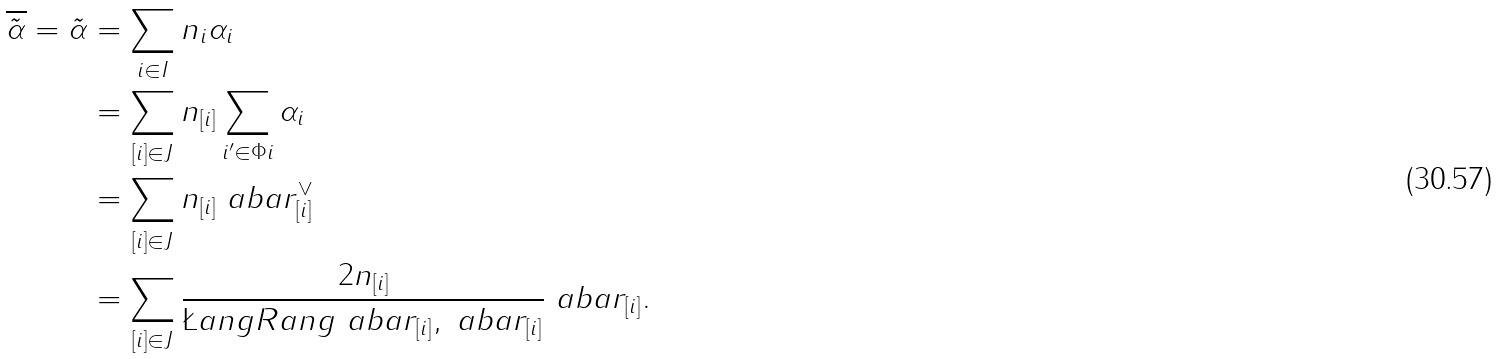<formula> <loc_0><loc_0><loc_500><loc_500>\overline { \tilde { \alpha } } = \tilde { \alpha } & = \sum _ { i \in I } n _ { i } \alpha _ { i } \\ & = \sum _ { [ i ] \in J } n _ { [ i ] } \sum _ { i ^ { \prime } \in \Phi i } \alpha _ { i } \\ & = \sum _ { [ i ] \in J } n _ { [ i ] } \ a b a r _ { [ i ] } ^ { \vee } \\ & = \sum _ { [ i ] \in J } \frac { 2 n _ { [ i ] } } { \L a n g R a n g { \ a b a r _ { [ i ] } , \ a b a r _ { [ i ] } } } \ a b a r _ { [ i ] } .</formula> 